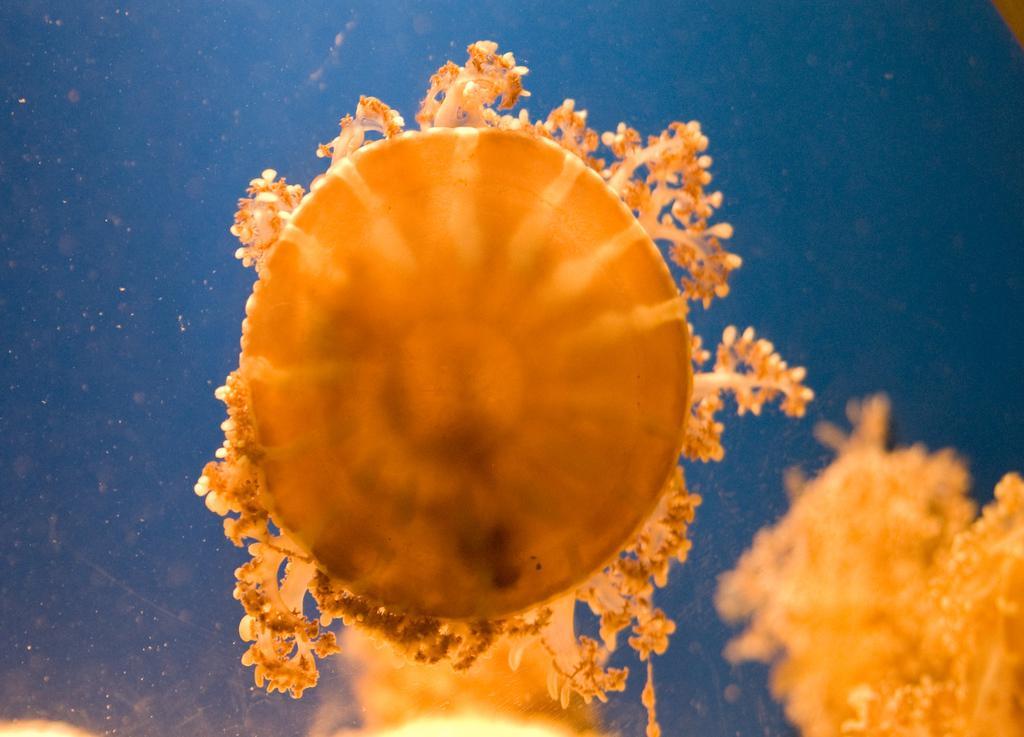Please provide a concise description of this image. In the image we can see water. In the water there are some underwater animals. 